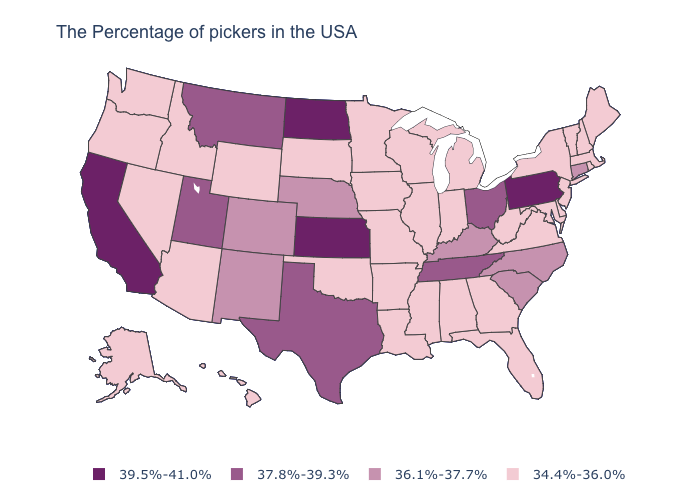Which states have the lowest value in the South?
Be succinct. Delaware, Maryland, Virginia, West Virginia, Florida, Georgia, Alabama, Mississippi, Louisiana, Arkansas, Oklahoma. Is the legend a continuous bar?
Concise answer only. No. Name the states that have a value in the range 34.4%-36.0%?
Give a very brief answer. Maine, Massachusetts, Rhode Island, New Hampshire, Vermont, New York, New Jersey, Delaware, Maryland, Virginia, West Virginia, Florida, Georgia, Michigan, Indiana, Alabama, Wisconsin, Illinois, Mississippi, Louisiana, Missouri, Arkansas, Minnesota, Iowa, Oklahoma, South Dakota, Wyoming, Arizona, Idaho, Nevada, Washington, Oregon, Alaska, Hawaii. Does Idaho have the lowest value in the USA?
Give a very brief answer. Yes. Is the legend a continuous bar?
Answer briefly. No. What is the lowest value in states that border Delaware?
Answer briefly. 34.4%-36.0%. What is the highest value in states that border Utah?
Be succinct. 36.1%-37.7%. Name the states that have a value in the range 34.4%-36.0%?
Concise answer only. Maine, Massachusetts, Rhode Island, New Hampshire, Vermont, New York, New Jersey, Delaware, Maryland, Virginia, West Virginia, Florida, Georgia, Michigan, Indiana, Alabama, Wisconsin, Illinois, Mississippi, Louisiana, Missouri, Arkansas, Minnesota, Iowa, Oklahoma, South Dakota, Wyoming, Arizona, Idaho, Nevada, Washington, Oregon, Alaska, Hawaii. Does Pennsylvania have the highest value in the Northeast?
Write a very short answer. Yes. What is the value of Rhode Island?
Give a very brief answer. 34.4%-36.0%. What is the lowest value in states that border Maine?
Keep it brief. 34.4%-36.0%. Among the states that border Maine , which have the lowest value?
Keep it brief. New Hampshire. What is the highest value in the Northeast ?
Be succinct. 39.5%-41.0%. What is the value of Rhode Island?
Answer briefly. 34.4%-36.0%. Which states hav the highest value in the South?
Be succinct. Tennessee, Texas. 